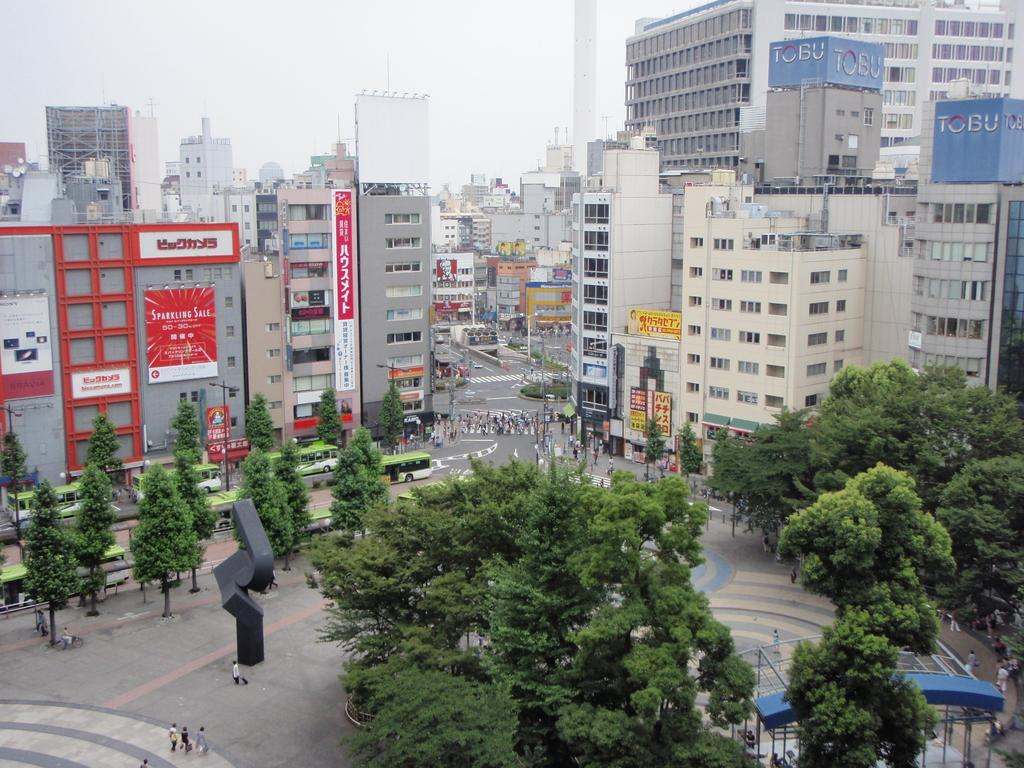What type of vegetation can be seen in the image? There are trees in the image. What are the people in the image doing? The people in the image are walking on the road. What type of structures are visible in the image? There are buildings in the image. What is visible at the top of the image? The sky is visible at the top of the image. What type of stew is being served in the image? There is no stew present in the image; it features trees, people walking on the road, buildings, and the sky. How does the image provide comfort to the viewer? The image itself does not provide comfort to the viewer, as it is a static representation of a scene. 